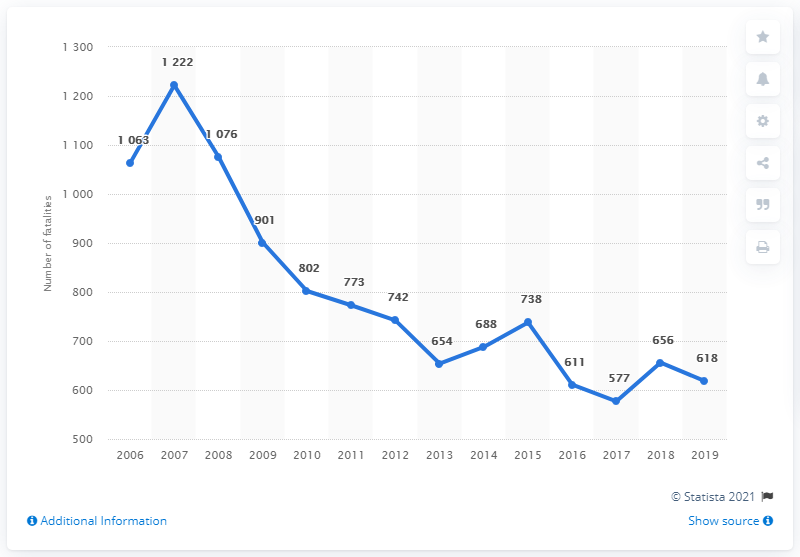Mention a couple of crucial points in this snapshot. In 2007, the line graph reached its highest peak. The difference between the maximum and minimum number of road fatalities over the years is 645. In 2019, there were 618 road traffic fatalities in the Czech Republic. 